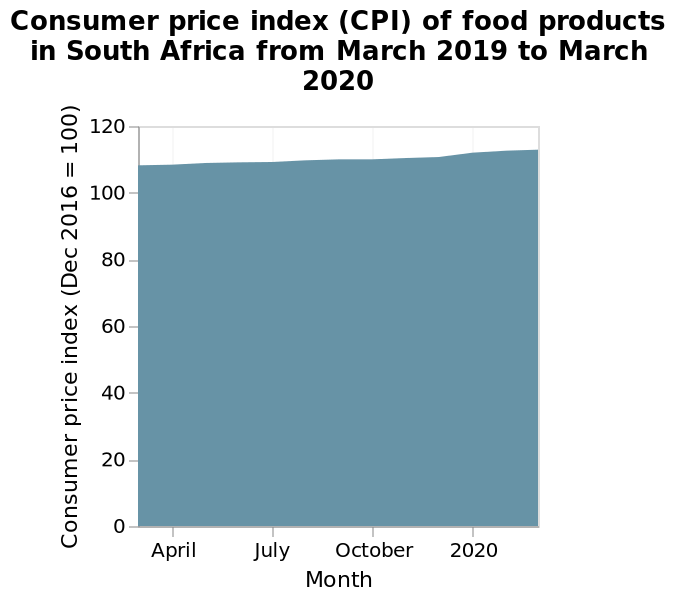<image>
please summary the statistics and relations of the chart The consumer price index between March 2019 and March 2020 were almost the same in this year with a slow increase. What is the name of the graph?  The graph is named "Consumer price index (CPI) of food products in South Africa from March 2019 to March 2020." 